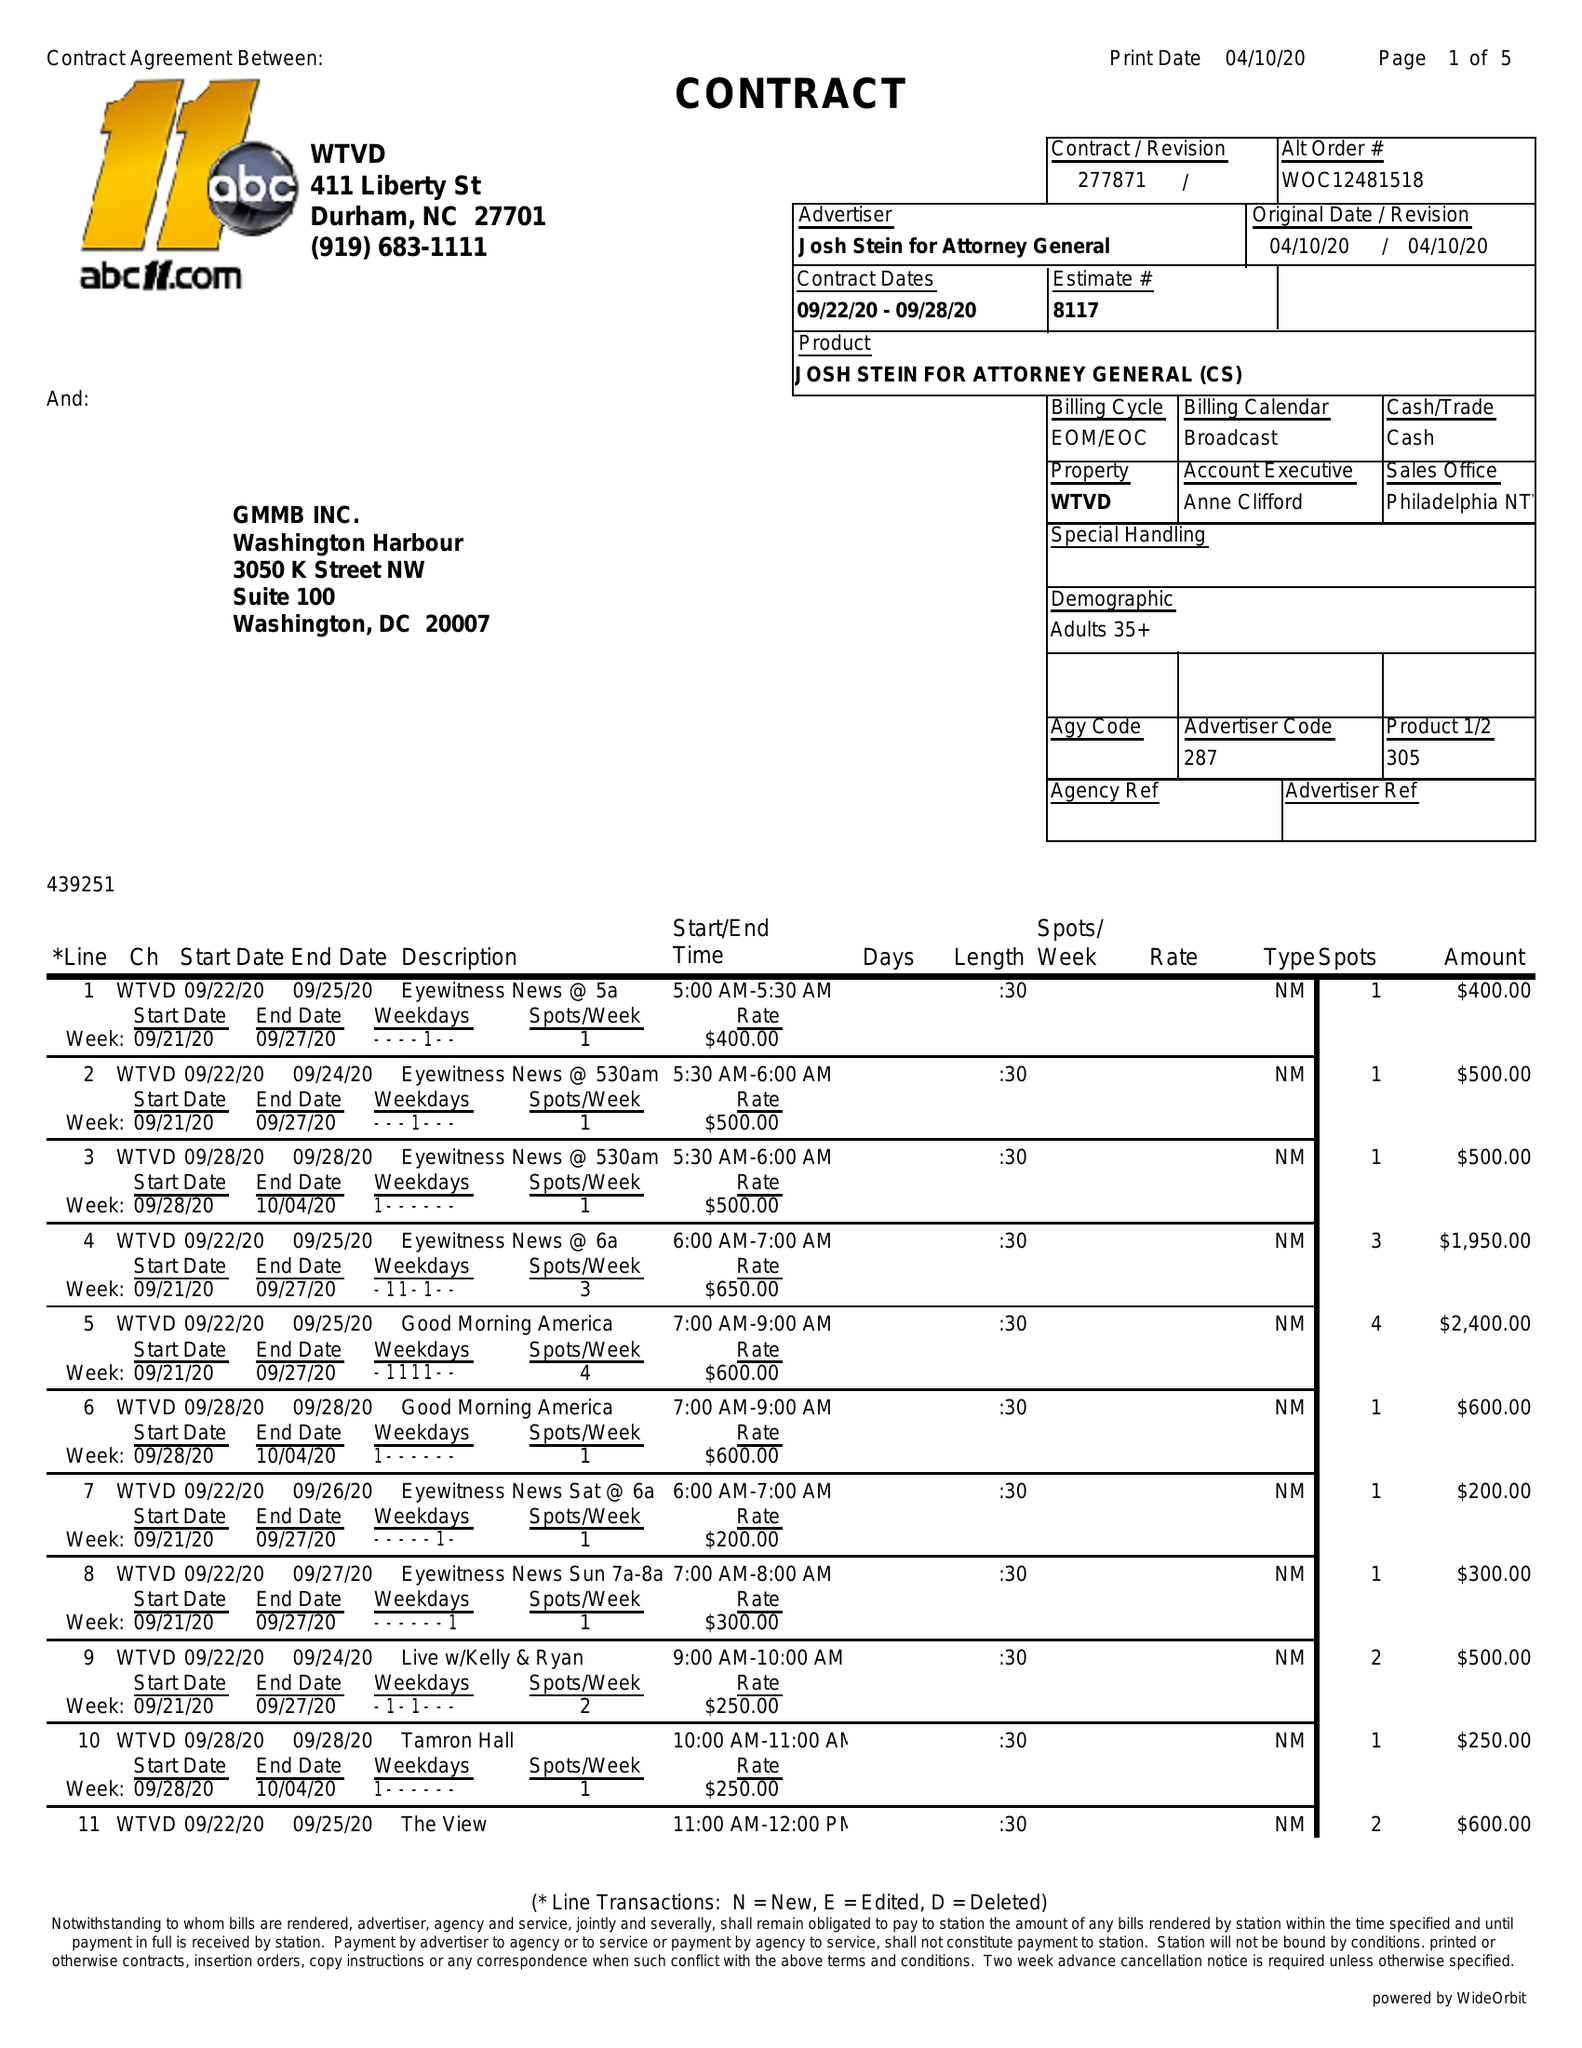What is the value for the flight_from?
Answer the question using a single word or phrase. 09/22/20 